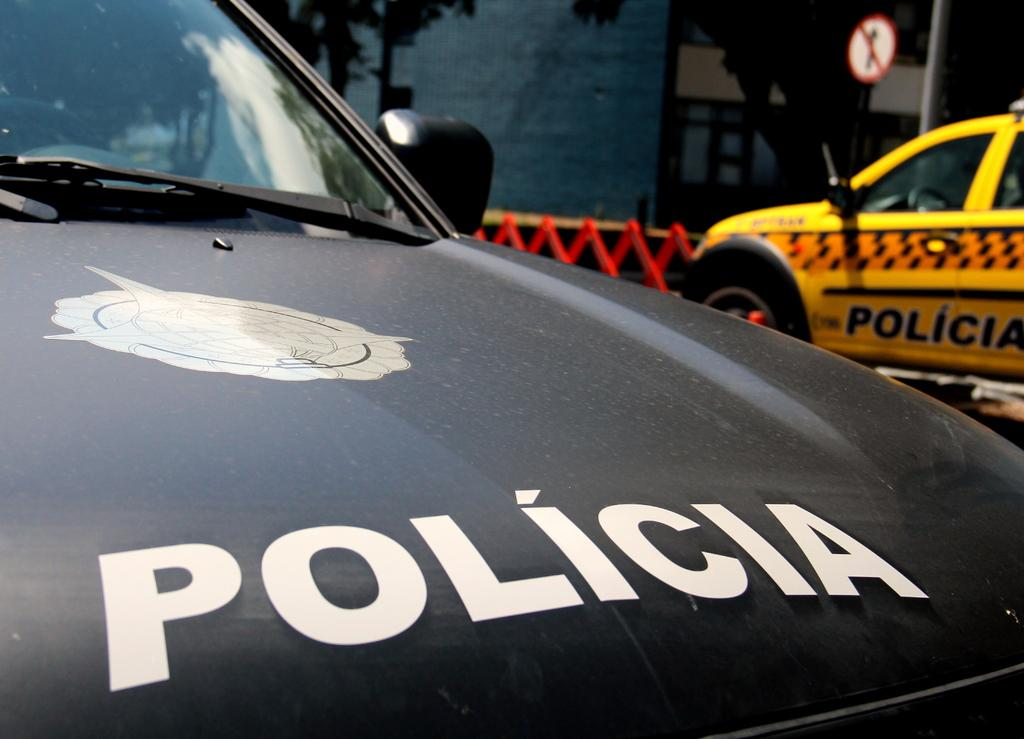<image>
Summarize the visual content of the image. two policia cars parked besides each other on the street 